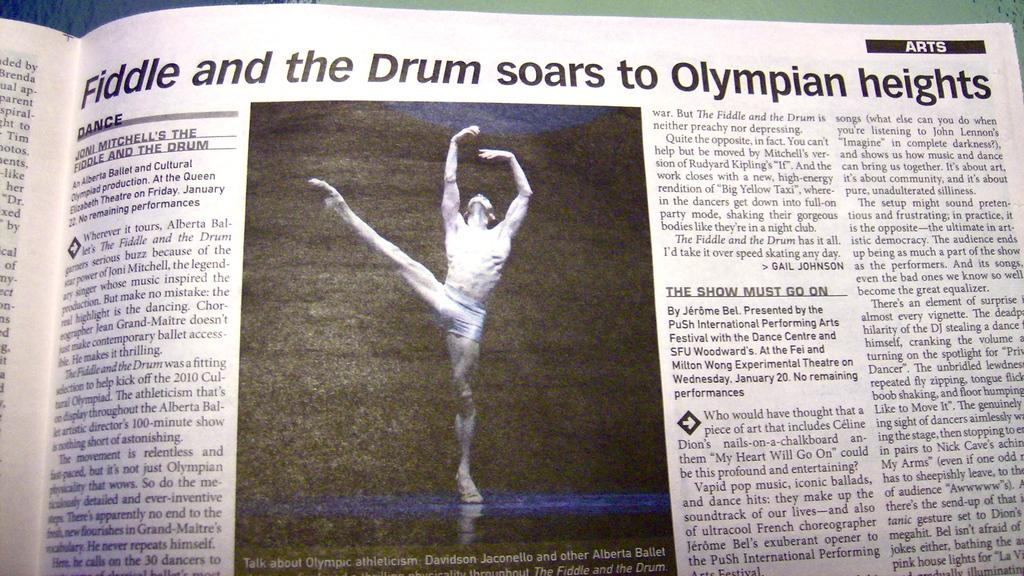<image>
Provide a brief description of the given image. arts section of paper with a photo of a ballet dancer 